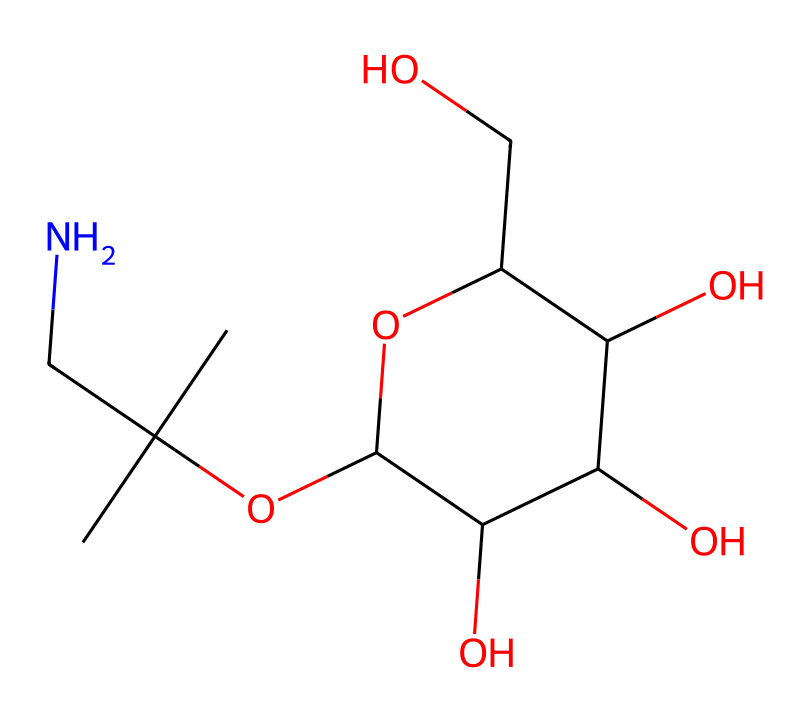What is the molecular formula of linamarin? To determine the molecular formula from the SMILES representation, count the number of each type of atom in the structure. The SMILES indicates the presence of 10 carbon (C) atoms, 17 hydrogen (H) atoms, 1 nitrogen (N) atom, and 6 oxygen (O) atoms. Therefore, the molecular formula is C10H17N1O6.
Answer: C10H17NO6 How many oxygen atoms are present in linamarin? By examining the SMILES string, we can observe that there are six 'O' characters, indicating the presence of six oxygen atoms in the structure of linamarin.
Answer: 6 Which part of the chemical structure indicates it has a nitrile functional group? The nitrile functional group is characterized by the presence of a carbon atom triple-bonded to a nitrogen atom (C≡N). In this SMILES representation, the 'CN' shows the carbon is connected to the nitrogen in this way.
Answer: CN Is linamarin a linear or branched molecule? Analyzing the structure depicted by the SMILES, we can see that it has a branched structure due to the presence of substituents on the main carbon chain, indicating that it is not linear but branched.
Answer: branched What is the primary type of glycoside that linamarin belongs to? Linamarin is categorized as a cyanogenic glycoside, as it contains a sugar part and a cyanide part. The presence of the nitrile indicates its classification as such.
Answer: cyanogenic glycoside What are the main components derived from linamarin? The main components produced from linamarin upon hydrolysis are glucose and a toxic compound called hydrogen cyanide. This indicates that the molecule can yield these substances when broken down.
Answer: glucose and hydrogen cyanide 